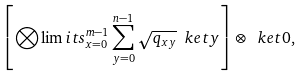<formula> <loc_0><loc_0><loc_500><loc_500>\left [ \bigotimes \lim i t s _ { x = 0 } ^ { m - 1 } \sum _ { y = 0 } ^ { n - 1 } \sqrt { q _ { x y } } \ k e t { y } \right ] \otimes \ k e t { 0 } ,</formula> 